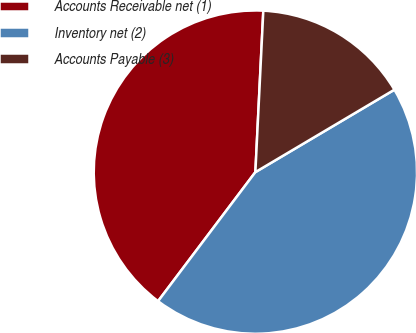Convert chart. <chart><loc_0><loc_0><loc_500><loc_500><pie_chart><fcel>Accounts Receivable net (1)<fcel>Inventory net (2)<fcel>Accounts Payable (3)<nl><fcel>40.5%<fcel>43.8%<fcel>15.7%<nl></chart> 